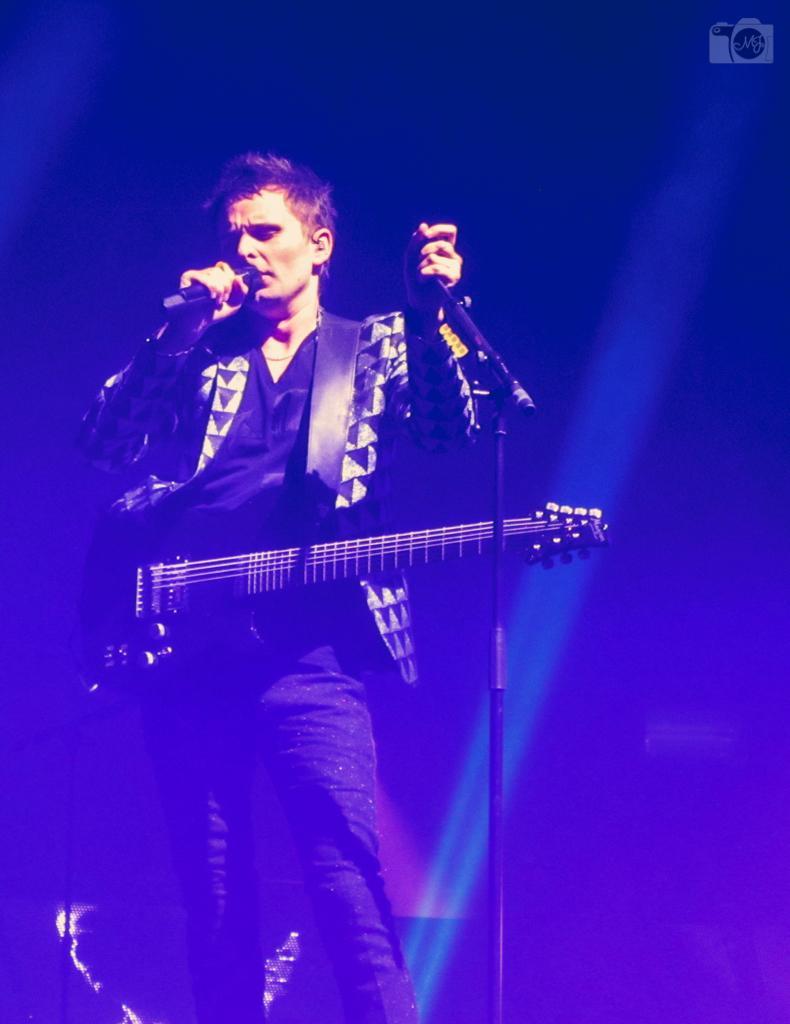Please provide a concise description of this image. There is a man singing a song by using a mike. He is holding guitar. This is a mike with a mike stand. This looks like he is doing a stage performance. 